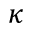<formula> <loc_0><loc_0><loc_500><loc_500>\kappa</formula> 